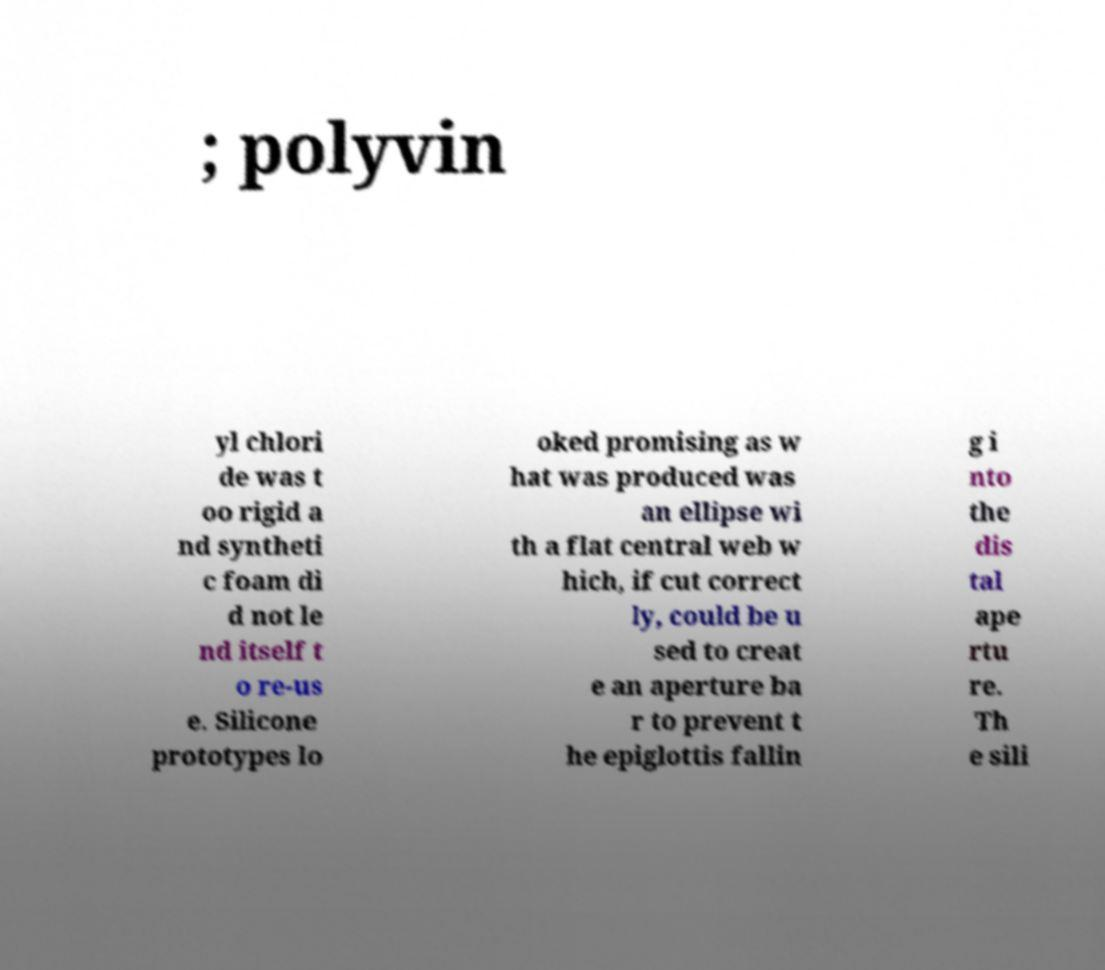Can you read and provide the text displayed in the image?This photo seems to have some interesting text. Can you extract and type it out for me? ; polyvin yl chlori de was t oo rigid a nd syntheti c foam di d not le nd itself t o re-us e. Silicone prototypes lo oked promising as w hat was produced was an ellipse wi th a flat central web w hich, if cut correct ly, could be u sed to creat e an aperture ba r to prevent t he epiglottis fallin g i nto the dis tal ape rtu re. Th e sili 